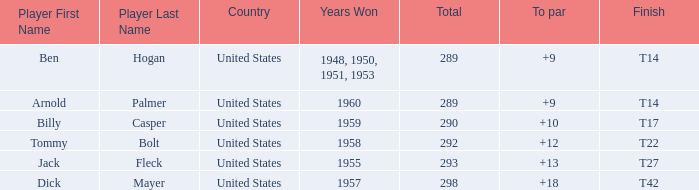What is Player, when Total is 292? Tommy Bolt. Help me parse the entirety of this table. {'header': ['Player First Name', 'Player Last Name', 'Country', 'Years Won', 'Total', 'To par', 'Finish'], 'rows': [['Ben', 'Hogan', 'United States', '1948, 1950, 1951, 1953', '289', '+9', 'T14'], ['Arnold', 'Palmer', 'United States', '1960', '289', '+9', 'T14'], ['Billy', 'Casper', 'United States', '1959', '290', '+10', 'T17'], ['Tommy', 'Bolt', 'United States', '1958', '292', '+12', 'T22'], ['Jack', 'Fleck', 'United States', '1955', '293', '+13', 'T27'], ['Dick', 'Mayer', 'United States', '1957', '298', '+18', 'T42']]} 